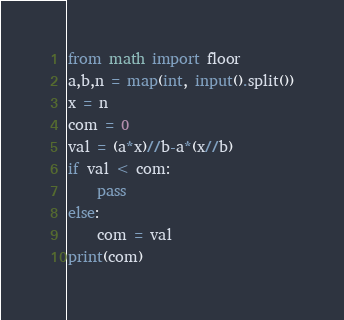Convert code to text. <code><loc_0><loc_0><loc_500><loc_500><_Python_>from math import floor
a,b,n = map(int, input().split())
x = n
com = 0
val = (a*x)//b-a*(x//b)
if val < com:
    pass
else:
    com = val
print(com)</code> 